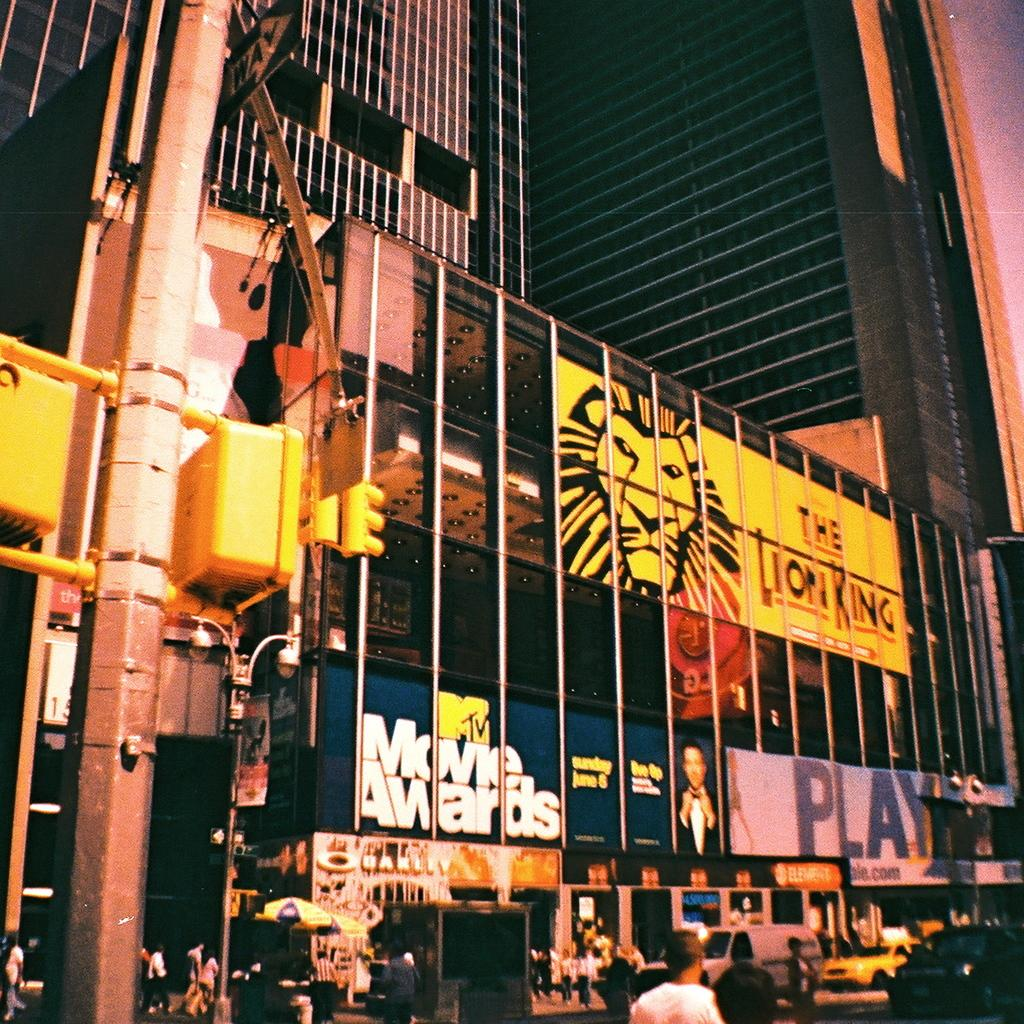<image>
Describe the image concisely. billboard ads on a building's windows read The Lion King and MTV Movie Awards 